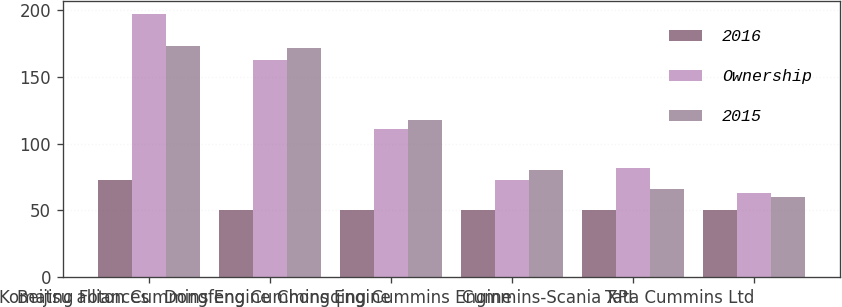Convert chart. <chart><loc_0><loc_0><loc_500><loc_500><stacked_bar_chart><ecel><fcel>Komatsu alliances<fcel>Beijing Foton Cummins Engine<fcel>Dongfeng Cummins Engine<fcel>Chongqing Cummins Engine<fcel>Cummins-Scania XPI<fcel>Tata Cummins Ltd<nl><fcel>2016<fcel>73<fcel>50<fcel>50<fcel>50<fcel>50<fcel>50<nl><fcel>Ownership<fcel>197<fcel>163<fcel>111<fcel>73<fcel>82<fcel>63<nl><fcel>2015<fcel>173<fcel>172<fcel>118<fcel>80<fcel>66<fcel>60<nl></chart> 